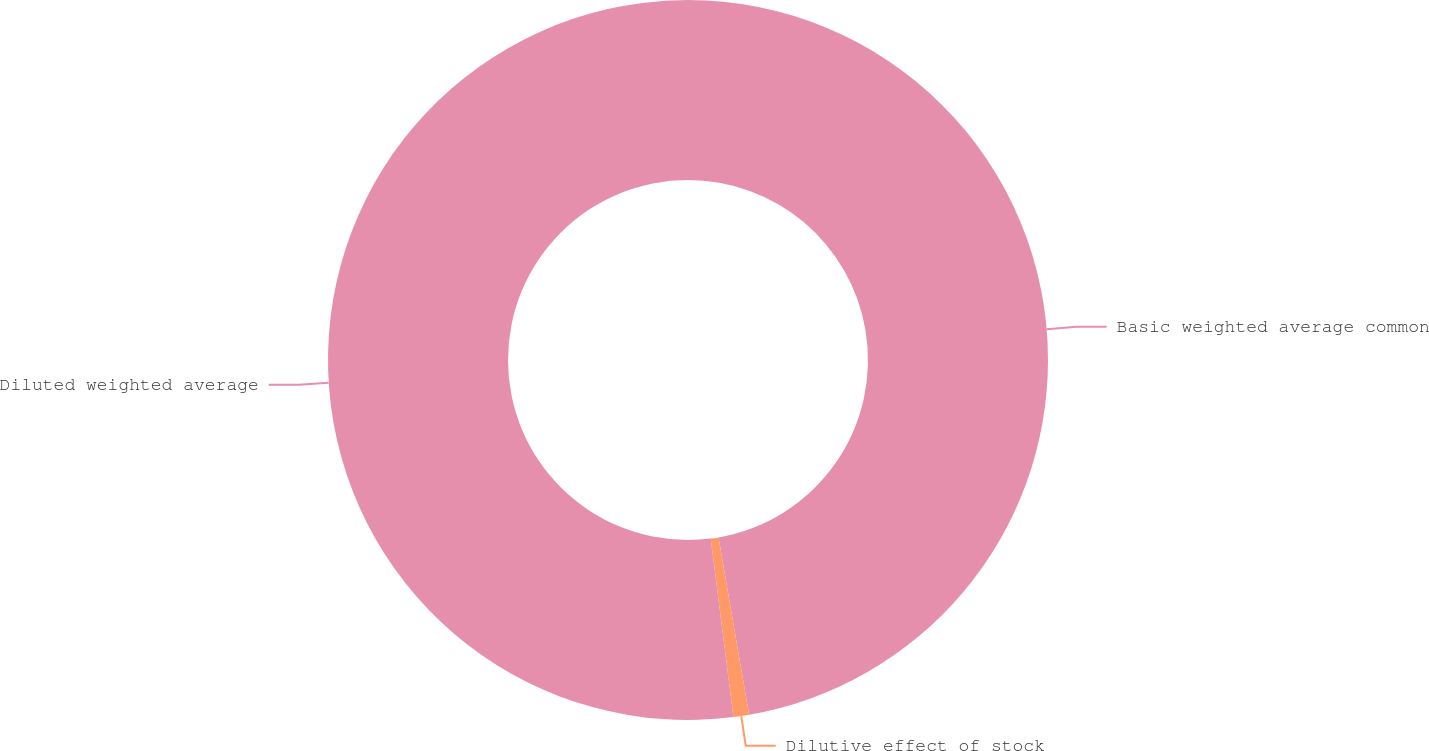<chart> <loc_0><loc_0><loc_500><loc_500><pie_chart><fcel>Basic weighted average common<fcel>Dilutive effect of stock<fcel>Diluted weighted average<nl><fcel>47.29%<fcel>0.7%<fcel>52.02%<nl></chart> 